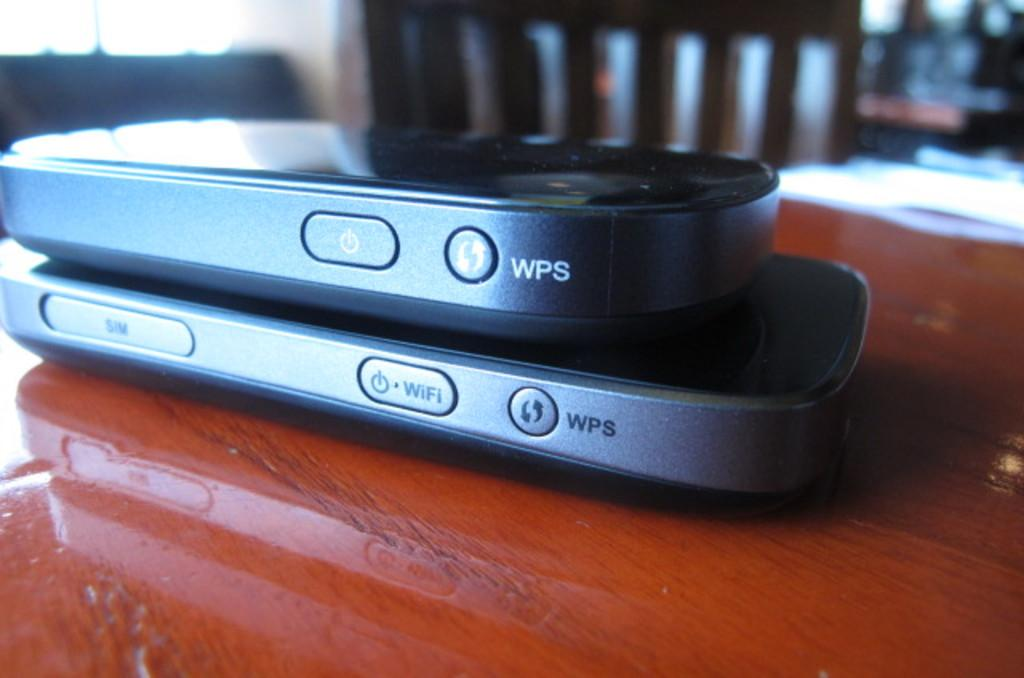<image>
Provide a brief description of the given image. Two phones stacked on each other with WPS buttons on them. 